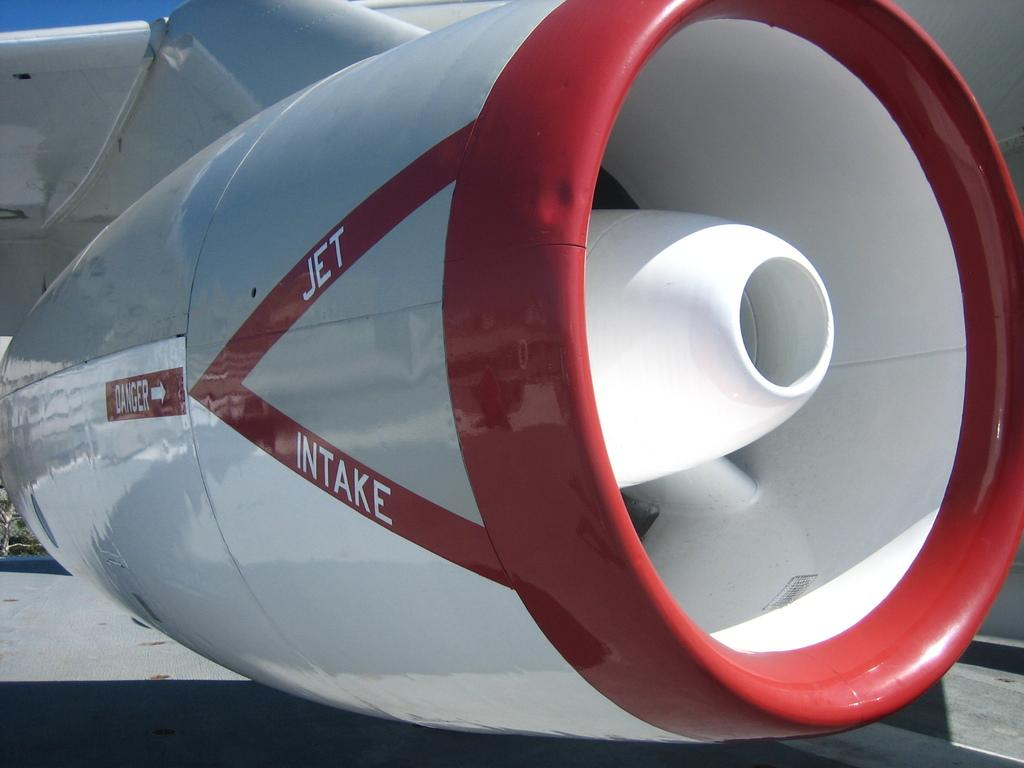<image>
Render a clear and concise summary of the photo. A plane turbine has Jet Intake painted on it. 